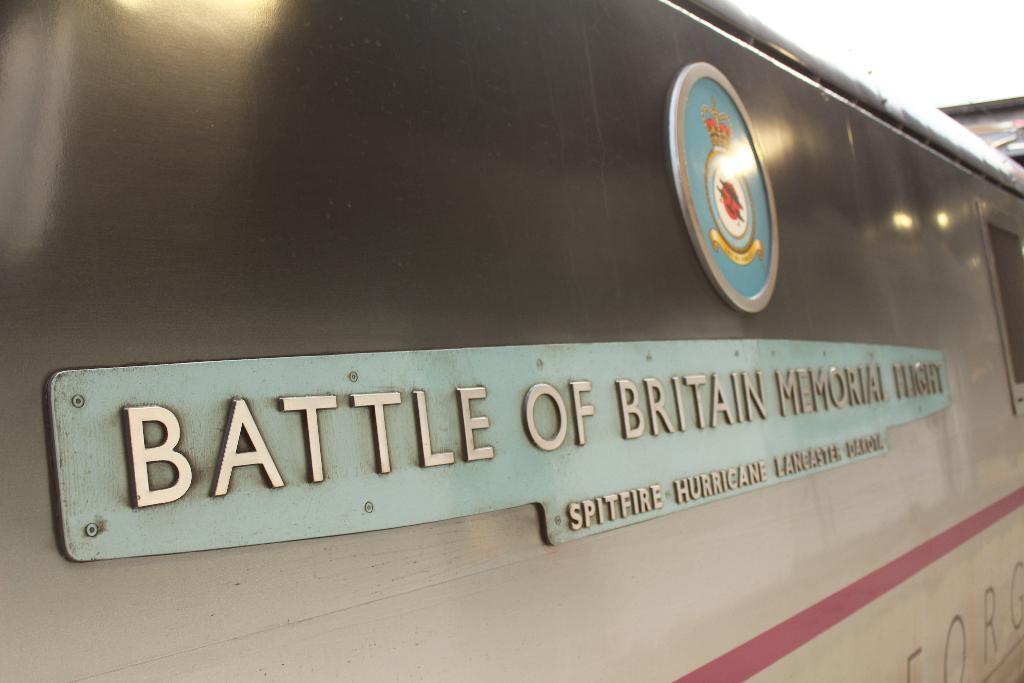Can you describe this image briefly? In this image we can see two boards on the surface and some text written on it. 